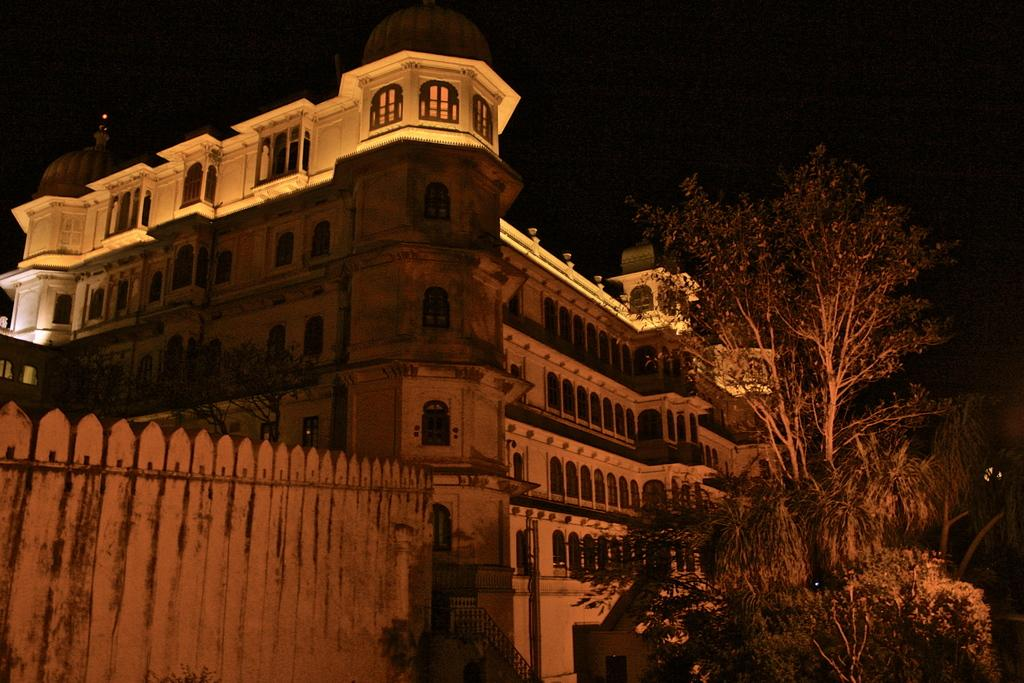What type of structure is located on the right side of the image? There is a building on the right side of the image. What is in front of the building? There are trees in front of the building. What can be seen on the left side of the image? There is a gate on the left side of the image. Can you tell me how many fish are swimming in the gate on the left side of the image? There are no fish present in the image, and the gate does not contain any water for fish to swim in. 